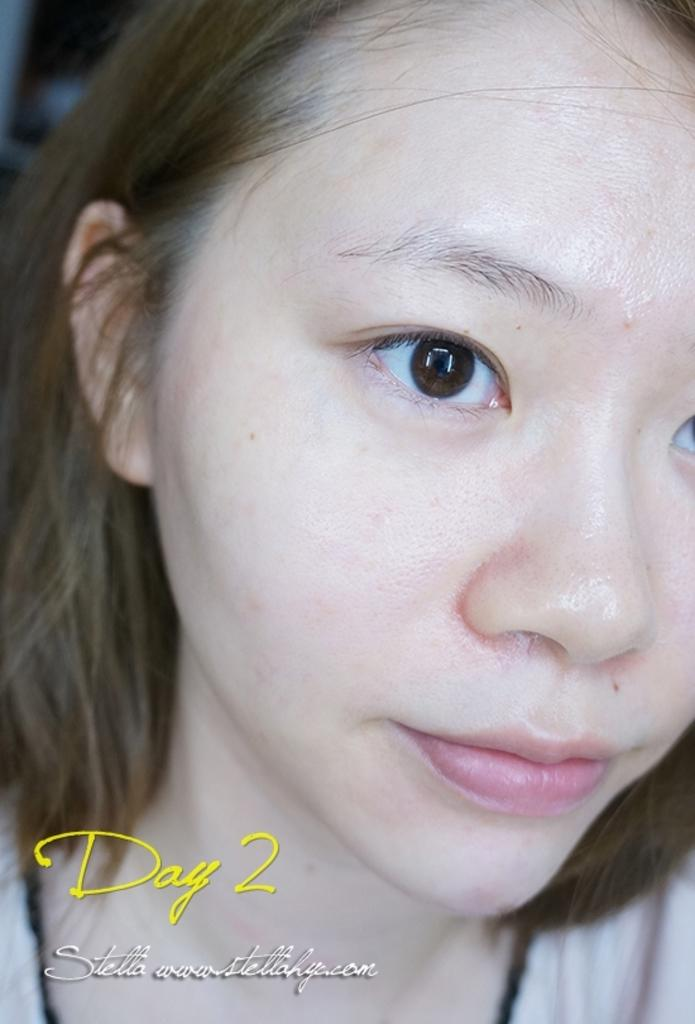Who is the main subject in the image? There is a lady in the image. What else can be seen at the bottom of the image? There is text at the bottom of the image. How many visitors are present in the image? There is no mention of visitors in the image; it only features a lady and text at the bottom. 